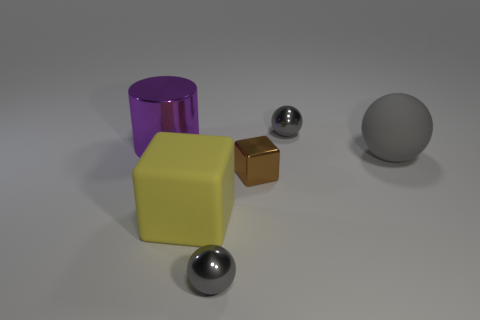There is a cylinder that is the same size as the yellow thing; what material is it?
Your answer should be compact. Metal. Do the ball behind the matte ball and the rubber ball have the same color?
Your answer should be compact. Yes. What is the material of the big thing that is both behind the tiny brown thing and left of the metal cube?
Make the answer very short. Metal. The gray matte ball is what size?
Provide a succinct answer. Large. Do the rubber ball and the tiny sphere behind the yellow thing have the same color?
Keep it short and to the point. Yes. How many other objects are the same color as the big rubber sphere?
Make the answer very short. 2. Do the object behind the cylinder and the matte thing that is left of the large gray sphere have the same size?
Provide a succinct answer. No. What is the color of the big rubber object that is in front of the matte ball?
Give a very brief answer. Yellow. Are there fewer metal spheres that are in front of the large block than small gray balls?
Your answer should be compact. Yes. Do the yellow thing and the large gray ball have the same material?
Provide a succinct answer. Yes. 